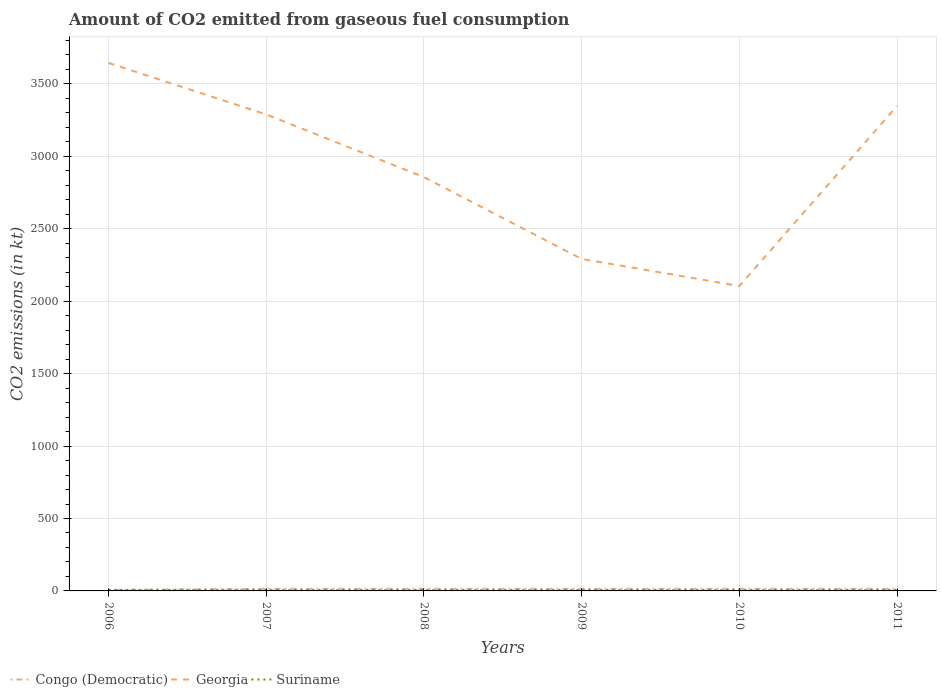How many different coloured lines are there?
Keep it short and to the point. 3. Does the line corresponding to Georgia intersect with the line corresponding to Congo (Democratic)?
Give a very brief answer. No. Is the number of lines equal to the number of legend labels?
Your answer should be very brief. Yes. Across all years, what is the maximum amount of CO2 emitted in Congo (Democratic)?
Provide a succinct answer. 7.33. In which year was the amount of CO2 emitted in Suriname maximum?
Offer a very short reply. 2006. What is the total amount of CO2 emitted in Congo (Democratic) in the graph?
Offer a very short reply. -7.33. What is the difference between the highest and the second highest amount of CO2 emitted in Congo (Democratic)?
Your answer should be very brief. 7.33. What is the difference between the highest and the lowest amount of CO2 emitted in Georgia?
Your answer should be very brief. 3. How many lines are there?
Provide a short and direct response. 3. How many years are there in the graph?
Provide a succinct answer. 6. Does the graph contain grids?
Offer a very short reply. Yes. Where does the legend appear in the graph?
Give a very brief answer. Bottom left. How are the legend labels stacked?
Your answer should be very brief. Horizontal. What is the title of the graph?
Give a very brief answer. Amount of CO2 emitted from gaseous fuel consumption. Does "Hungary" appear as one of the legend labels in the graph?
Provide a short and direct response. No. What is the label or title of the Y-axis?
Your response must be concise. CO2 emissions (in kt). What is the CO2 emissions (in kt) of Congo (Democratic) in 2006?
Provide a short and direct response. 7.33. What is the CO2 emissions (in kt) in Georgia in 2006?
Give a very brief answer. 3645. What is the CO2 emissions (in kt) in Suriname in 2006?
Offer a terse response. 7.33. What is the CO2 emissions (in kt) in Congo (Democratic) in 2007?
Your answer should be very brief. 14.67. What is the CO2 emissions (in kt) of Georgia in 2007?
Keep it short and to the point. 3289.3. What is the CO2 emissions (in kt) of Suriname in 2007?
Make the answer very short. 7.33. What is the CO2 emissions (in kt) of Congo (Democratic) in 2008?
Your answer should be very brief. 14.67. What is the CO2 emissions (in kt) of Georgia in 2008?
Keep it short and to the point. 2856.59. What is the CO2 emissions (in kt) of Suriname in 2008?
Your answer should be very brief. 7.33. What is the CO2 emissions (in kt) of Congo (Democratic) in 2009?
Keep it short and to the point. 14.67. What is the CO2 emissions (in kt) in Georgia in 2009?
Provide a short and direct response. 2291.88. What is the CO2 emissions (in kt) in Suriname in 2009?
Offer a very short reply. 7.33. What is the CO2 emissions (in kt) of Congo (Democratic) in 2010?
Provide a short and direct response. 14.67. What is the CO2 emissions (in kt) of Georgia in 2010?
Give a very brief answer. 2104.86. What is the CO2 emissions (in kt) in Suriname in 2010?
Provide a succinct answer. 7.33. What is the CO2 emissions (in kt) in Congo (Democratic) in 2011?
Keep it short and to the point. 14.67. What is the CO2 emissions (in kt) of Georgia in 2011?
Ensure brevity in your answer.  3347.97. What is the CO2 emissions (in kt) in Suriname in 2011?
Offer a terse response. 7.33. Across all years, what is the maximum CO2 emissions (in kt) of Congo (Democratic)?
Your answer should be very brief. 14.67. Across all years, what is the maximum CO2 emissions (in kt) in Georgia?
Ensure brevity in your answer.  3645. Across all years, what is the maximum CO2 emissions (in kt) of Suriname?
Your answer should be compact. 7.33. Across all years, what is the minimum CO2 emissions (in kt) in Congo (Democratic)?
Keep it short and to the point. 7.33. Across all years, what is the minimum CO2 emissions (in kt) in Georgia?
Make the answer very short. 2104.86. Across all years, what is the minimum CO2 emissions (in kt) of Suriname?
Offer a very short reply. 7.33. What is the total CO2 emissions (in kt) in Congo (Democratic) in the graph?
Offer a terse response. 80.67. What is the total CO2 emissions (in kt) in Georgia in the graph?
Keep it short and to the point. 1.75e+04. What is the total CO2 emissions (in kt) in Suriname in the graph?
Your answer should be compact. 44. What is the difference between the CO2 emissions (in kt) in Congo (Democratic) in 2006 and that in 2007?
Provide a succinct answer. -7.33. What is the difference between the CO2 emissions (in kt) of Georgia in 2006 and that in 2007?
Keep it short and to the point. 355.7. What is the difference between the CO2 emissions (in kt) of Suriname in 2006 and that in 2007?
Give a very brief answer. 0. What is the difference between the CO2 emissions (in kt) in Congo (Democratic) in 2006 and that in 2008?
Offer a terse response. -7.33. What is the difference between the CO2 emissions (in kt) of Georgia in 2006 and that in 2008?
Provide a succinct answer. 788.4. What is the difference between the CO2 emissions (in kt) of Congo (Democratic) in 2006 and that in 2009?
Your response must be concise. -7.33. What is the difference between the CO2 emissions (in kt) of Georgia in 2006 and that in 2009?
Ensure brevity in your answer.  1353.12. What is the difference between the CO2 emissions (in kt) of Suriname in 2006 and that in 2009?
Provide a succinct answer. 0. What is the difference between the CO2 emissions (in kt) in Congo (Democratic) in 2006 and that in 2010?
Your response must be concise. -7.33. What is the difference between the CO2 emissions (in kt) of Georgia in 2006 and that in 2010?
Give a very brief answer. 1540.14. What is the difference between the CO2 emissions (in kt) in Suriname in 2006 and that in 2010?
Your answer should be compact. 0. What is the difference between the CO2 emissions (in kt) of Congo (Democratic) in 2006 and that in 2011?
Provide a succinct answer. -7.33. What is the difference between the CO2 emissions (in kt) in Georgia in 2006 and that in 2011?
Keep it short and to the point. 297.03. What is the difference between the CO2 emissions (in kt) of Suriname in 2006 and that in 2011?
Keep it short and to the point. 0. What is the difference between the CO2 emissions (in kt) of Georgia in 2007 and that in 2008?
Provide a short and direct response. 432.71. What is the difference between the CO2 emissions (in kt) in Suriname in 2007 and that in 2008?
Your response must be concise. 0. What is the difference between the CO2 emissions (in kt) of Georgia in 2007 and that in 2009?
Ensure brevity in your answer.  997.42. What is the difference between the CO2 emissions (in kt) in Georgia in 2007 and that in 2010?
Offer a very short reply. 1184.44. What is the difference between the CO2 emissions (in kt) in Suriname in 2007 and that in 2010?
Your answer should be very brief. 0. What is the difference between the CO2 emissions (in kt) in Georgia in 2007 and that in 2011?
Provide a short and direct response. -58.67. What is the difference between the CO2 emissions (in kt) in Suriname in 2007 and that in 2011?
Make the answer very short. 0. What is the difference between the CO2 emissions (in kt) of Congo (Democratic) in 2008 and that in 2009?
Provide a succinct answer. 0. What is the difference between the CO2 emissions (in kt) of Georgia in 2008 and that in 2009?
Provide a succinct answer. 564.72. What is the difference between the CO2 emissions (in kt) of Suriname in 2008 and that in 2009?
Make the answer very short. 0. What is the difference between the CO2 emissions (in kt) of Georgia in 2008 and that in 2010?
Give a very brief answer. 751.74. What is the difference between the CO2 emissions (in kt) in Georgia in 2008 and that in 2011?
Your answer should be very brief. -491.38. What is the difference between the CO2 emissions (in kt) of Suriname in 2008 and that in 2011?
Ensure brevity in your answer.  0. What is the difference between the CO2 emissions (in kt) of Congo (Democratic) in 2009 and that in 2010?
Ensure brevity in your answer.  0. What is the difference between the CO2 emissions (in kt) in Georgia in 2009 and that in 2010?
Your response must be concise. 187.02. What is the difference between the CO2 emissions (in kt) of Congo (Democratic) in 2009 and that in 2011?
Provide a succinct answer. 0. What is the difference between the CO2 emissions (in kt) in Georgia in 2009 and that in 2011?
Offer a very short reply. -1056.1. What is the difference between the CO2 emissions (in kt) of Suriname in 2009 and that in 2011?
Keep it short and to the point. 0. What is the difference between the CO2 emissions (in kt) of Congo (Democratic) in 2010 and that in 2011?
Keep it short and to the point. 0. What is the difference between the CO2 emissions (in kt) of Georgia in 2010 and that in 2011?
Provide a succinct answer. -1243.11. What is the difference between the CO2 emissions (in kt) of Suriname in 2010 and that in 2011?
Provide a short and direct response. 0. What is the difference between the CO2 emissions (in kt) in Congo (Democratic) in 2006 and the CO2 emissions (in kt) in Georgia in 2007?
Provide a short and direct response. -3281.97. What is the difference between the CO2 emissions (in kt) of Georgia in 2006 and the CO2 emissions (in kt) of Suriname in 2007?
Offer a terse response. 3637.66. What is the difference between the CO2 emissions (in kt) in Congo (Democratic) in 2006 and the CO2 emissions (in kt) in Georgia in 2008?
Offer a very short reply. -2849.26. What is the difference between the CO2 emissions (in kt) in Congo (Democratic) in 2006 and the CO2 emissions (in kt) in Suriname in 2008?
Make the answer very short. 0. What is the difference between the CO2 emissions (in kt) in Georgia in 2006 and the CO2 emissions (in kt) in Suriname in 2008?
Your answer should be compact. 3637.66. What is the difference between the CO2 emissions (in kt) of Congo (Democratic) in 2006 and the CO2 emissions (in kt) of Georgia in 2009?
Give a very brief answer. -2284.54. What is the difference between the CO2 emissions (in kt) in Congo (Democratic) in 2006 and the CO2 emissions (in kt) in Suriname in 2009?
Make the answer very short. 0. What is the difference between the CO2 emissions (in kt) of Georgia in 2006 and the CO2 emissions (in kt) of Suriname in 2009?
Provide a succinct answer. 3637.66. What is the difference between the CO2 emissions (in kt) of Congo (Democratic) in 2006 and the CO2 emissions (in kt) of Georgia in 2010?
Give a very brief answer. -2097.52. What is the difference between the CO2 emissions (in kt) of Georgia in 2006 and the CO2 emissions (in kt) of Suriname in 2010?
Your answer should be very brief. 3637.66. What is the difference between the CO2 emissions (in kt) in Congo (Democratic) in 2006 and the CO2 emissions (in kt) in Georgia in 2011?
Provide a short and direct response. -3340.64. What is the difference between the CO2 emissions (in kt) in Congo (Democratic) in 2006 and the CO2 emissions (in kt) in Suriname in 2011?
Ensure brevity in your answer.  0. What is the difference between the CO2 emissions (in kt) of Georgia in 2006 and the CO2 emissions (in kt) of Suriname in 2011?
Your response must be concise. 3637.66. What is the difference between the CO2 emissions (in kt) in Congo (Democratic) in 2007 and the CO2 emissions (in kt) in Georgia in 2008?
Make the answer very short. -2841.93. What is the difference between the CO2 emissions (in kt) of Congo (Democratic) in 2007 and the CO2 emissions (in kt) of Suriname in 2008?
Your answer should be very brief. 7.33. What is the difference between the CO2 emissions (in kt) in Georgia in 2007 and the CO2 emissions (in kt) in Suriname in 2008?
Provide a succinct answer. 3281.97. What is the difference between the CO2 emissions (in kt) of Congo (Democratic) in 2007 and the CO2 emissions (in kt) of Georgia in 2009?
Offer a terse response. -2277.21. What is the difference between the CO2 emissions (in kt) of Congo (Democratic) in 2007 and the CO2 emissions (in kt) of Suriname in 2009?
Your answer should be compact. 7.33. What is the difference between the CO2 emissions (in kt) in Georgia in 2007 and the CO2 emissions (in kt) in Suriname in 2009?
Keep it short and to the point. 3281.97. What is the difference between the CO2 emissions (in kt) of Congo (Democratic) in 2007 and the CO2 emissions (in kt) of Georgia in 2010?
Your answer should be very brief. -2090.19. What is the difference between the CO2 emissions (in kt) of Congo (Democratic) in 2007 and the CO2 emissions (in kt) of Suriname in 2010?
Give a very brief answer. 7.33. What is the difference between the CO2 emissions (in kt) in Georgia in 2007 and the CO2 emissions (in kt) in Suriname in 2010?
Your response must be concise. 3281.97. What is the difference between the CO2 emissions (in kt) in Congo (Democratic) in 2007 and the CO2 emissions (in kt) in Georgia in 2011?
Your answer should be very brief. -3333.3. What is the difference between the CO2 emissions (in kt) of Congo (Democratic) in 2007 and the CO2 emissions (in kt) of Suriname in 2011?
Your answer should be very brief. 7.33. What is the difference between the CO2 emissions (in kt) in Georgia in 2007 and the CO2 emissions (in kt) in Suriname in 2011?
Offer a terse response. 3281.97. What is the difference between the CO2 emissions (in kt) in Congo (Democratic) in 2008 and the CO2 emissions (in kt) in Georgia in 2009?
Offer a terse response. -2277.21. What is the difference between the CO2 emissions (in kt) in Congo (Democratic) in 2008 and the CO2 emissions (in kt) in Suriname in 2009?
Your answer should be very brief. 7.33. What is the difference between the CO2 emissions (in kt) of Georgia in 2008 and the CO2 emissions (in kt) of Suriname in 2009?
Your answer should be very brief. 2849.26. What is the difference between the CO2 emissions (in kt) in Congo (Democratic) in 2008 and the CO2 emissions (in kt) in Georgia in 2010?
Your response must be concise. -2090.19. What is the difference between the CO2 emissions (in kt) in Congo (Democratic) in 2008 and the CO2 emissions (in kt) in Suriname in 2010?
Make the answer very short. 7.33. What is the difference between the CO2 emissions (in kt) of Georgia in 2008 and the CO2 emissions (in kt) of Suriname in 2010?
Your answer should be very brief. 2849.26. What is the difference between the CO2 emissions (in kt) in Congo (Democratic) in 2008 and the CO2 emissions (in kt) in Georgia in 2011?
Provide a short and direct response. -3333.3. What is the difference between the CO2 emissions (in kt) in Congo (Democratic) in 2008 and the CO2 emissions (in kt) in Suriname in 2011?
Provide a succinct answer. 7.33. What is the difference between the CO2 emissions (in kt) in Georgia in 2008 and the CO2 emissions (in kt) in Suriname in 2011?
Provide a succinct answer. 2849.26. What is the difference between the CO2 emissions (in kt) in Congo (Democratic) in 2009 and the CO2 emissions (in kt) in Georgia in 2010?
Provide a succinct answer. -2090.19. What is the difference between the CO2 emissions (in kt) of Congo (Democratic) in 2009 and the CO2 emissions (in kt) of Suriname in 2010?
Your answer should be compact. 7.33. What is the difference between the CO2 emissions (in kt) in Georgia in 2009 and the CO2 emissions (in kt) in Suriname in 2010?
Keep it short and to the point. 2284.54. What is the difference between the CO2 emissions (in kt) in Congo (Democratic) in 2009 and the CO2 emissions (in kt) in Georgia in 2011?
Your answer should be very brief. -3333.3. What is the difference between the CO2 emissions (in kt) in Congo (Democratic) in 2009 and the CO2 emissions (in kt) in Suriname in 2011?
Make the answer very short. 7.33. What is the difference between the CO2 emissions (in kt) of Georgia in 2009 and the CO2 emissions (in kt) of Suriname in 2011?
Your answer should be very brief. 2284.54. What is the difference between the CO2 emissions (in kt) in Congo (Democratic) in 2010 and the CO2 emissions (in kt) in Georgia in 2011?
Ensure brevity in your answer.  -3333.3. What is the difference between the CO2 emissions (in kt) in Congo (Democratic) in 2010 and the CO2 emissions (in kt) in Suriname in 2011?
Give a very brief answer. 7.33. What is the difference between the CO2 emissions (in kt) in Georgia in 2010 and the CO2 emissions (in kt) in Suriname in 2011?
Give a very brief answer. 2097.52. What is the average CO2 emissions (in kt) in Congo (Democratic) per year?
Give a very brief answer. 13.45. What is the average CO2 emissions (in kt) in Georgia per year?
Offer a terse response. 2922.6. What is the average CO2 emissions (in kt) in Suriname per year?
Your answer should be very brief. 7.33. In the year 2006, what is the difference between the CO2 emissions (in kt) of Congo (Democratic) and CO2 emissions (in kt) of Georgia?
Ensure brevity in your answer.  -3637.66. In the year 2006, what is the difference between the CO2 emissions (in kt) of Georgia and CO2 emissions (in kt) of Suriname?
Keep it short and to the point. 3637.66. In the year 2007, what is the difference between the CO2 emissions (in kt) in Congo (Democratic) and CO2 emissions (in kt) in Georgia?
Your answer should be compact. -3274.63. In the year 2007, what is the difference between the CO2 emissions (in kt) in Congo (Democratic) and CO2 emissions (in kt) in Suriname?
Provide a succinct answer. 7.33. In the year 2007, what is the difference between the CO2 emissions (in kt) of Georgia and CO2 emissions (in kt) of Suriname?
Your answer should be compact. 3281.97. In the year 2008, what is the difference between the CO2 emissions (in kt) in Congo (Democratic) and CO2 emissions (in kt) in Georgia?
Provide a short and direct response. -2841.93. In the year 2008, what is the difference between the CO2 emissions (in kt) in Congo (Democratic) and CO2 emissions (in kt) in Suriname?
Make the answer very short. 7.33. In the year 2008, what is the difference between the CO2 emissions (in kt) of Georgia and CO2 emissions (in kt) of Suriname?
Provide a short and direct response. 2849.26. In the year 2009, what is the difference between the CO2 emissions (in kt) of Congo (Democratic) and CO2 emissions (in kt) of Georgia?
Offer a very short reply. -2277.21. In the year 2009, what is the difference between the CO2 emissions (in kt) in Congo (Democratic) and CO2 emissions (in kt) in Suriname?
Give a very brief answer. 7.33. In the year 2009, what is the difference between the CO2 emissions (in kt) of Georgia and CO2 emissions (in kt) of Suriname?
Offer a terse response. 2284.54. In the year 2010, what is the difference between the CO2 emissions (in kt) of Congo (Democratic) and CO2 emissions (in kt) of Georgia?
Ensure brevity in your answer.  -2090.19. In the year 2010, what is the difference between the CO2 emissions (in kt) of Congo (Democratic) and CO2 emissions (in kt) of Suriname?
Your answer should be compact. 7.33. In the year 2010, what is the difference between the CO2 emissions (in kt) in Georgia and CO2 emissions (in kt) in Suriname?
Make the answer very short. 2097.52. In the year 2011, what is the difference between the CO2 emissions (in kt) in Congo (Democratic) and CO2 emissions (in kt) in Georgia?
Your answer should be compact. -3333.3. In the year 2011, what is the difference between the CO2 emissions (in kt) of Congo (Democratic) and CO2 emissions (in kt) of Suriname?
Your response must be concise. 7.33. In the year 2011, what is the difference between the CO2 emissions (in kt) in Georgia and CO2 emissions (in kt) in Suriname?
Your response must be concise. 3340.64. What is the ratio of the CO2 emissions (in kt) of Congo (Democratic) in 2006 to that in 2007?
Offer a very short reply. 0.5. What is the ratio of the CO2 emissions (in kt) of Georgia in 2006 to that in 2007?
Provide a short and direct response. 1.11. What is the ratio of the CO2 emissions (in kt) in Congo (Democratic) in 2006 to that in 2008?
Your answer should be very brief. 0.5. What is the ratio of the CO2 emissions (in kt) of Georgia in 2006 to that in 2008?
Your response must be concise. 1.28. What is the ratio of the CO2 emissions (in kt) in Congo (Democratic) in 2006 to that in 2009?
Provide a succinct answer. 0.5. What is the ratio of the CO2 emissions (in kt) in Georgia in 2006 to that in 2009?
Keep it short and to the point. 1.59. What is the ratio of the CO2 emissions (in kt) of Georgia in 2006 to that in 2010?
Your response must be concise. 1.73. What is the ratio of the CO2 emissions (in kt) of Congo (Democratic) in 2006 to that in 2011?
Offer a terse response. 0.5. What is the ratio of the CO2 emissions (in kt) in Georgia in 2006 to that in 2011?
Provide a succinct answer. 1.09. What is the ratio of the CO2 emissions (in kt) of Suriname in 2006 to that in 2011?
Ensure brevity in your answer.  1. What is the ratio of the CO2 emissions (in kt) of Congo (Democratic) in 2007 to that in 2008?
Ensure brevity in your answer.  1. What is the ratio of the CO2 emissions (in kt) of Georgia in 2007 to that in 2008?
Your answer should be compact. 1.15. What is the ratio of the CO2 emissions (in kt) in Congo (Democratic) in 2007 to that in 2009?
Keep it short and to the point. 1. What is the ratio of the CO2 emissions (in kt) in Georgia in 2007 to that in 2009?
Offer a terse response. 1.44. What is the ratio of the CO2 emissions (in kt) of Suriname in 2007 to that in 2009?
Make the answer very short. 1. What is the ratio of the CO2 emissions (in kt) in Georgia in 2007 to that in 2010?
Offer a terse response. 1.56. What is the ratio of the CO2 emissions (in kt) in Suriname in 2007 to that in 2010?
Offer a very short reply. 1. What is the ratio of the CO2 emissions (in kt) in Congo (Democratic) in 2007 to that in 2011?
Your answer should be very brief. 1. What is the ratio of the CO2 emissions (in kt) in Georgia in 2007 to that in 2011?
Keep it short and to the point. 0.98. What is the ratio of the CO2 emissions (in kt) in Suriname in 2007 to that in 2011?
Give a very brief answer. 1. What is the ratio of the CO2 emissions (in kt) in Georgia in 2008 to that in 2009?
Keep it short and to the point. 1.25. What is the ratio of the CO2 emissions (in kt) of Georgia in 2008 to that in 2010?
Your response must be concise. 1.36. What is the ratio of the CO2 emissions (in kt) of Suriname in 2008 to that in 2010?
Give a very brief answer. 1. What is the ratio of the CO2 emissions (in kt) in Congo (Democratic) in 2008 to that in 2011?
Provide a succinct answer. 1. What is the ratio of the CO2 emissions (in kt) of Georgia in 2008 to that in 2011?
Your answer should be very brief. 0.85. What is the ratio of the CO2 emissions (in kt) of Suriname in 2008 to that in 2011?
Offer a very short reply. 1. What is the ratio of the CO2 emissions (in kt) of Georgia in 2009 to that in 2010?
Your answer should be compact. 1.09. What is the ratio of the CO2 emissions (in kt) of Suriname in 2009 to that in 2010?
Offer a terse response. 1. What is the ratio of the CO2 emissions (in kt) in Congo (Democratic) in 2009 to that in 2011?
Keep it short and to the point. 1. What is the ratio of the CO2 emissions (in kt) in Georgia in 2009 to that in 2011?
Provide a succinct answer. 0.68. What is the ratio of the CO2 emissions (in kt) in Congo (Democratic) in 2010 to that in 2011?
Your answer should be very brief. 1. What is the ratio of the CO2 emissions (in kt) of Georgia in 2010 to that in 2011?
Provide a short and direct response. 0.63. What is the ratio of the CO2 emissions (in kt) in Suriname in 2010 to that in 2011?
Offer a terse response. 1. What is the difference between the highest and the second highest CO2 emissions (in kt) of Georgia?
Provide a short and direct response. 297.03. What is the difference between the highest and the lowest CO2 emissions (in kt) of Congo (Democratic)?
Make the answer very short. 7.33. What is the difference between the highest and the lowest CO2 emissions (in kt) of Georgia?
Your answer should be very brief. 1540.14. 